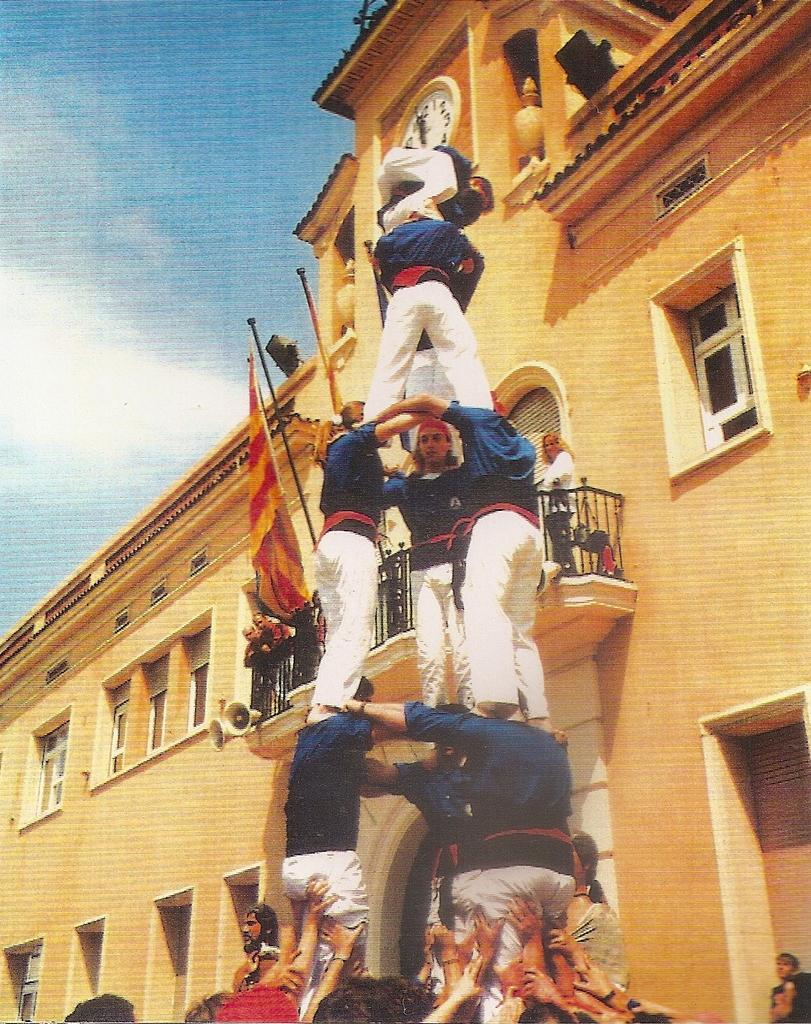What is the main subject in the center of the image? There is a human pyramid in the center of the image. What can be seen in the background of the image? There is a building with windows in the background of the image. What is the additional object present in the image? There is a flag in the image. What is visible at the top of the image? The sky is visible at the top of the image. How many pies are being held by the people in the human pyramid? There are no pies present in the image; the human pyramid consists of people only. 